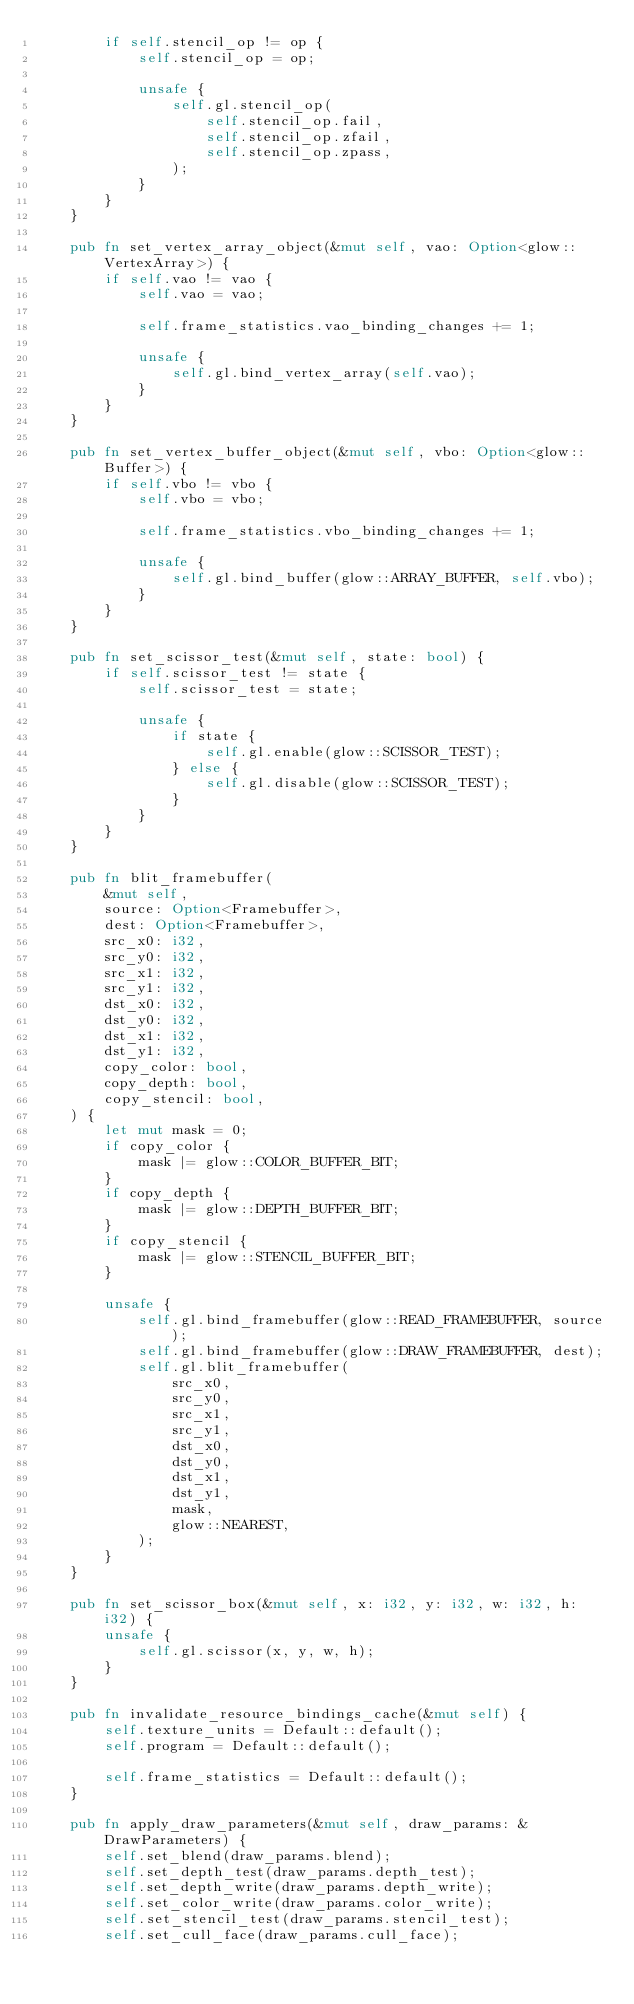Convert code to text. <code><loc_0><loc_0><loc_500><loc_500><_Rust_>        if self.stencil_op != op {
            self.stencil_op = op;

            unsafe {
                self.gl.stencil_op(
                    self.stencil_op.fail,
                    self.stencil_op.zfail,
                    self.stencil_op.zpass,
                );
            }
        }
    }

    pub fn set_vertex_array_object(&mut self, vao: Option<glow::VertexArray>) {
        if self.vao != vao {
            self.vao = vao;

            self.frame_statistics.vao_binding_changes += 1;

            unsafe {
                self.gl.bind_vertex_array(self.vao);
            }
        }
    }

    pub fn set_vertex_buffer_object(&mut self, vbo: Option<glow::Buffer>) {
        if self.vbo != vbo {
            self.vbo = vbo;

            self.frame_statistics.vbo_binding_changes += 1;

            unsafe {
                self.gl.bind_buffer(glow::ARRAY_BUFFER, self.vbo);
            }
        }
    }

    pub fn set_scissor_test(&mut self, state: bool) {
        if self.scissor_test != state {
            self.scissor_test = state;

            unsafe {
                if state {
                    self.gl.enable(glow::SCISSOR_TEST);
                } else {
                    self.gl.disable(glow::SCISSOR_TEST);
                }
            }
        }
    }

    pub fn blit_framebuffer(
        &mut self,
        source: Option<Framebuffer>,
        dest: Option<Framebuffer>,
        src_x0: i32,
        src_y0: i32,
        src_x1: i32,
        src_y1: i32,
        dst_x0: i32,
        dst_y0: i32,
        dst_x1: i32,
        dst_y1: i32,
        copy_color: bool,
        copy_depth: bool,
        copy_stencil: bool,
    ) {
        let mut mask = 0;
        if copy_color {
            mask |= glow::COLOR_BUFFER_BIT;
        }
        if copy_depth {
            mask |= glow::DEPTH_BUFFER_BIT;
        }
        if copy_stencil {
            mask |= glow::STENCIL_BUFFER_BIT;
        }

        unsafe {
            self.gl.bind_framebuffer(glow::READ_FRAMEBUFFER, source);
            self.gl.bind_framebuffer(glow::DRAW_FRAMEBUFFER, dest);
            self.gl.blit_framebuffer(
                src_x0,
                src_y0,
                src_x1,
                src_y1,
                dst_x0,
                dst_y0,
                dst_x1,
                dst_y1,
                mask,
                glow::NEAREST,
            );
        }
    }

    pub fn set_scissor_box(&mut self, x: i32, y: i32, w: i32, h: i32) {
        unsafe {
            self.gl.scissor(x, y, w, h);
        }
    }

    pub fn invalidate_resource_bindings_cache(&mut self) {
        self.texture_units = Default::default();
        self.program = Default::default();

        self.frame_statistics = Default::default();
    }

    pub fn apply_draw_parameters(&mut self, draw_params: &DrawParameters) {
        self.set_blend(draw_params.blend);
        self.set_depth_test(draw_params.depth_test);
        self.set_depth_write(draw_params.depth_write);
        self.set_color_write(draw_params.color_write);
        self.set_stencil_test(draw_params.stencil_test);
        self.set_cull_face(draw_params.cull_face);</code> 